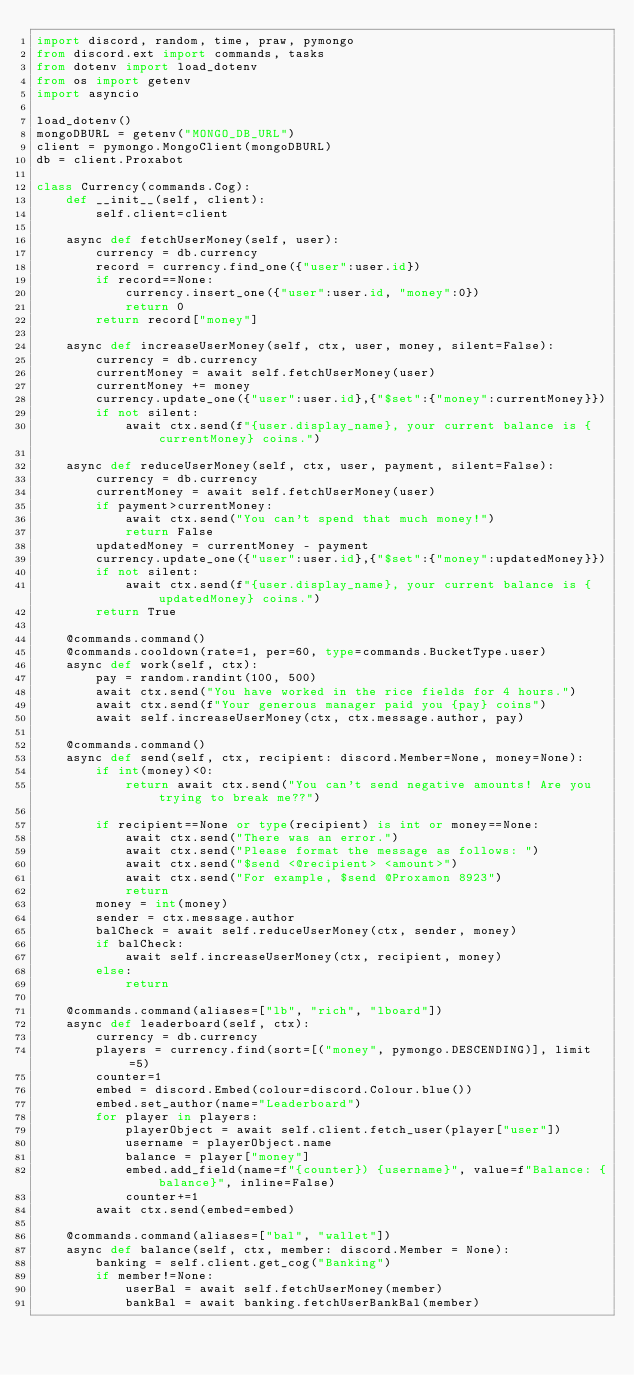Convert code to text. <code><loc_0><loc_0><loc_500><loc_500><_Python_>import discord, random, time, praw, pymongo
from discord.ext import commands, tasks
from dotenv import load_dotenv
from os import getenv
import asyncio

load_dotenv()
mongoDBURL = getenv("MONGO_DB_URL")
client = pymongo.MongoClient(mongoDBURL)
db = client.Proxabot

class Currency(commands.Cog):
    def __init__(self, client):
        self.client=client

    async def fetchUserMoney(self, user):
        currency = db.currency
        record = currency.find_one({"user":user.id})
        if record==None:
            currency.insert_one({"user":user.id, "money":0})
            return 0
        return record["money"]

    async def increaseUserMoney(self, ctx, user, money, silent=False):
        currency = db.currency
        currentMoney = await self.fetchUserMoney(user)
        currentMoney += money
        currency.update_one({"user":user.id},{"$set":{"money":currentMoney}})
        if not silent:
            await ctx.send(f"{user.display_name}, your current balance is {currentMoney} coins.")
    
    async def reduceUserMoney(self, ctx, user, payment, silent=False):
        currency = db.currency 
        currentMoney = await self.fetchUserMoney(user)
        if payment>currentMoney:
            await ctx.send("You can't spend that much money!")
            return False
        updatedMoney = currentMoney - payment
        currency.update_one({"user":user.id},{"$set":{"money":updatedMoney}})
        if not silent:
            await ctx.send(f"{user.display_name}, your current balance is {updatedMoney} coins.")
        return True

    @commands.command()
    @commands.cooldown(rate=1, per=60, type=commands.BucketType.user)
    async def work(self, ctx):
        pay = random.randint(100, 500)
        await ctx.send("You have worked in the rice fields for 4 hours.")
        await ctx.send(f"Your generous manager paid you {pay} coins")
        await self.increaseUserMoney(ctx, ctx.message.author, pay)

    @commands.command()
    async def send(self, ctx, recipient: discord.Member=None, money=None):
        if int(money)<0:
            return await ctx.send("You can't send negative amounts! Are you trying to break me??")

        if recipient==None or type(recipient) is int or money==None:
            await ctx.send("There was an error.")
            await ctx.send("Please format the message as follows: ")
            await ctx.send("$send <@recipient> <amount>")
            await ctx.send("For example, $send @Proxamon 8923")
            return
        money = int(money)
        sender = ctx.message.author
        balCheck = await self.reduceUserMoney(ctx, sender, money)
        if balCheck:
            await self.increaseUserMoney(ctx, recipient, money)
        else:
            return

    @commands.command(aliases=["lb", "rich", "lboard"])
    async def leaderboard(self, ctx):
        currency = db.currency
        players = currency.find(sort=[("money", pymongo.DESCENDING)], limit=5)
        counter=1
        embed = discord.Embed(colour=discord.Colour.blue())
        embed.set_author(name="Leaderboard")   
        for player in players:
            playerObject = await self.client.fetch_user(player["user"])
            username = playerObject.name 
            balance = player["money"]
            embed.add_field(name=f"{counter}) {username}", value=f"Balance: {balance}", inline=False)
            counter+=1
        await ctx.send(embed=embed)

    @commands.command(aliases=["bal", "wallet"])
    async def balance(self, ctx, member: discord.Member = None):
        banking = self.client.get_cog("Banking")
        if member!=None:
            userBal = await self.fetchUserMoney(member)
            bankBal = await banking.fetchUserBankBal(member)</code> 